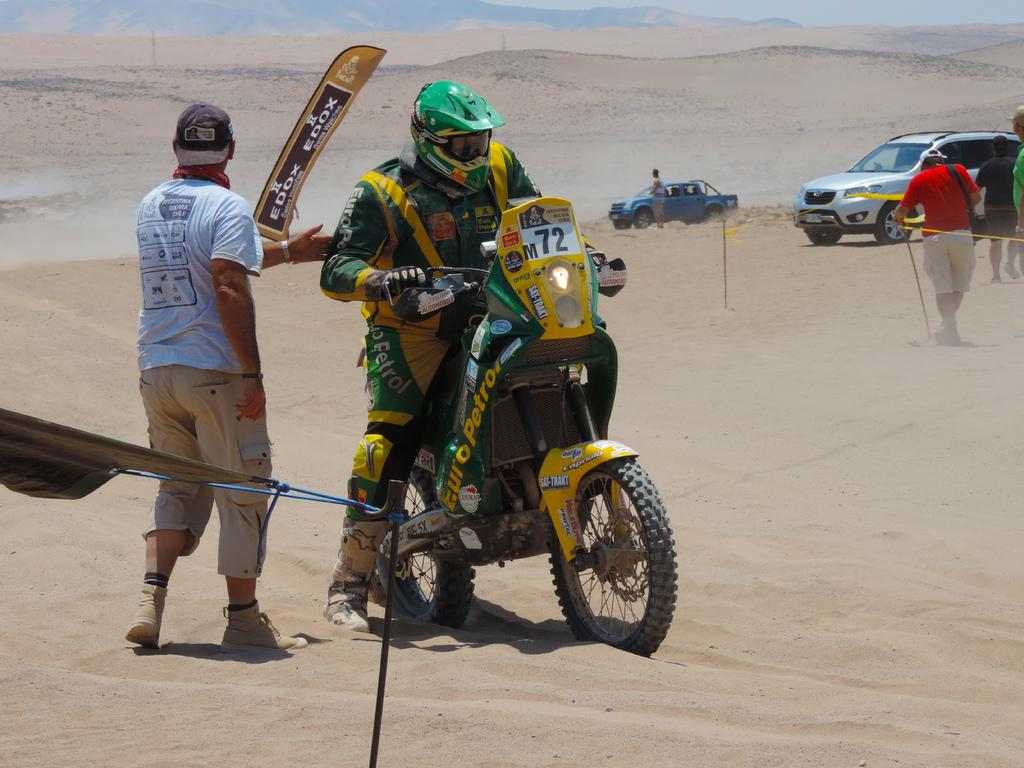What type of landscape can be seen in the background of the image? There are hills visible in the background of the image. What type of environment is depicted in the image? The image depicts a desert. What can be seen moving in the image? There are vehicles and people standing and walking in the image. What is the man in the image doing? There is a man sitting on a bike in the image. What type of monkey can be seen walking on its feet in the image? There are no monkeys present in the image; it depicts a desert with vehicles and people. 